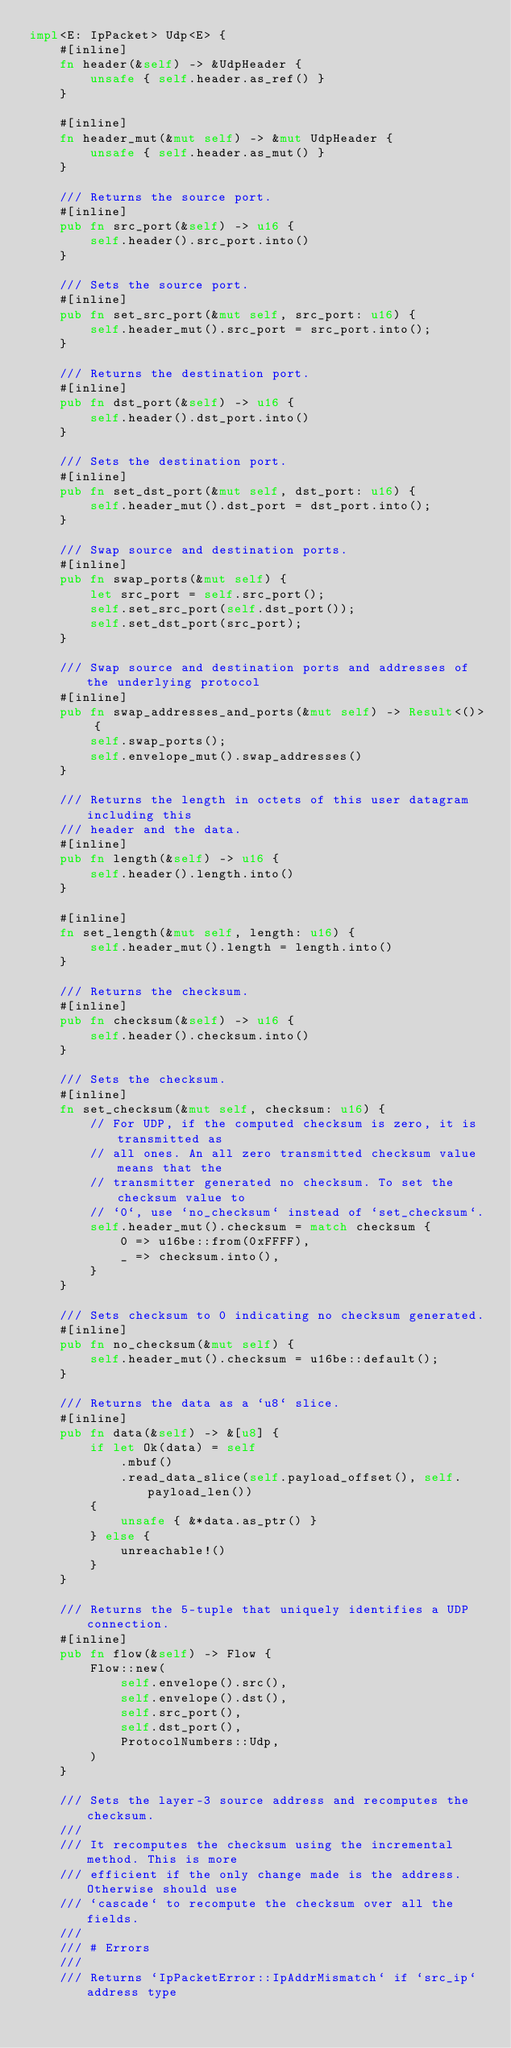Convert code to text. <code><loc_0><loc_0><loc_500><loc_500><_Rust_>impl<E: IpPacket> Udp<E> {
    #[inline]
    fn header(&self) -> &UdpHeader {
        unsafe { self.header.as_ref() }
    }

    #[inline]
    fn header_mut(&mut self) -> &mut UdpHeader {
        unsafe { self.header.as_mut() }
    }

    /// Returns the source port.
    #[inline]
    pub fn src_port(&self) -> u16 {
        self.header().src_port.into()
    }

    /// Sets the source port.
    #[inline]
    pub fn set_src_port(&mut self, src_port: u16) {
        self.header_mut().src_port = src_port.into();
    }

    /// Returns the destination port.
    #[inline]
    pub fn dst_port(&self) -> u16 {
        self.header().dst_port.into()
    }

    /// Sets the destination port.
    #[inline]
    pub fn set_dst_port(&mut self, dst_port: u16) {
        self.header_mut().dst_port = dst_port.into();
    }

    /// Swap source and destination ports.
    #[inline]
    pub fn swap_ports(&mut self) {
        let src_port = self.src_port();
        self.set_src_port(self.dst_port());
        self.set_dst_port(src_port);
    }

    /// Swap source and destination ports and addresses of the underlying protocol
    #[inline]
    pub fn swap_addresses_and_ports(&mut self) -> Result<()> {
        self.swap_ports();
        self.envelope_mut().swap_addresses()
    }

    /// Returns the length in octets of this user datagram including this
    /// header and the data.
    #[inline]
    pub fn length(&self) -> u16 {
        self.header().length.into()
    }

    #[inline]
    fn set_length(&mut self, length: u16) {
        self.header_mut().length = length.into()
    }

    /// Returns the checksum.
    #[inline]
    pub fn checksum(&self) -> u16 {
        self.header().checksum.into()
    }

    /// Sets the checksum.
    #[inline]
    fn set_checksum(&mut self, checksum: u16) {
        // For UDP, if the computed checksum is zero, it is transmitted as
        // all ones. An all zero transmitted checksum value means that the
        // transmitter generated no checksum. To set the checksum value to
        // `0`, use `no_checksum` instead of `set_checksum`.
        self.header_mut().checksum = match checksum {
            0 => u16be::from(0xFFFF),
            _ => checksum.into(),
        }
    }

    /// Sets checksum to 0 indicating no checksum generated.
    #[inline]
    pub fn no_checksum(&mut self) {
        self.header_mut().checksum = u16be::default();
    }

    /// Returns the data as a `u8` slice.
    #[inline]
    pub fn data(&self) -> &[u8] {
        if let Ok(data) = self
            .mbuf()
            .read_data_slice(self.payload_offset(), self.payload_len())
        {
            unsafe { &*data.as_ptr() }
        } else {
            unreachable!()
        }
    }

    /// Returns the 5-tuple that uniquely identifies a UDP connection.
    #[inline]
    pub fn flow(&self) -> Flow {
        Flow::new(
            self.envelope().src(),
            self.envelope().dst(),
            self.src_port(),
            self.dst_port(),
            ProtocolNumbers::Udp,
        )
    }

    /// Sets the layer-3 source address and recomputes the checksum.
    ///
    /// It recomputes the checksum using the incremental method. This is more
    /// efficient if the only change made is the address. Otherwise should use
    /// `cascade` to recompute the checksum over all the fields.
    ///
    /// # Errors
    ///
    /// Returns `IpPacketError::IpAddrMismatch` if `src_ip` address type</code> 